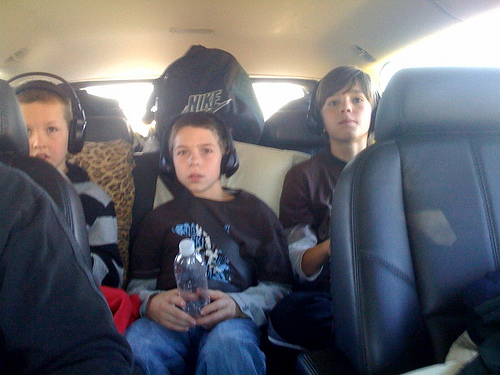<image>
Is the headphones on the kid? No. The headphones is not positioned on the kid. They may be near each other, but the headphones is not supported by or resting on top of the kid. Is the child in the bag? No. The child is not contained within the bag. These objects have a different spatial relationship. 